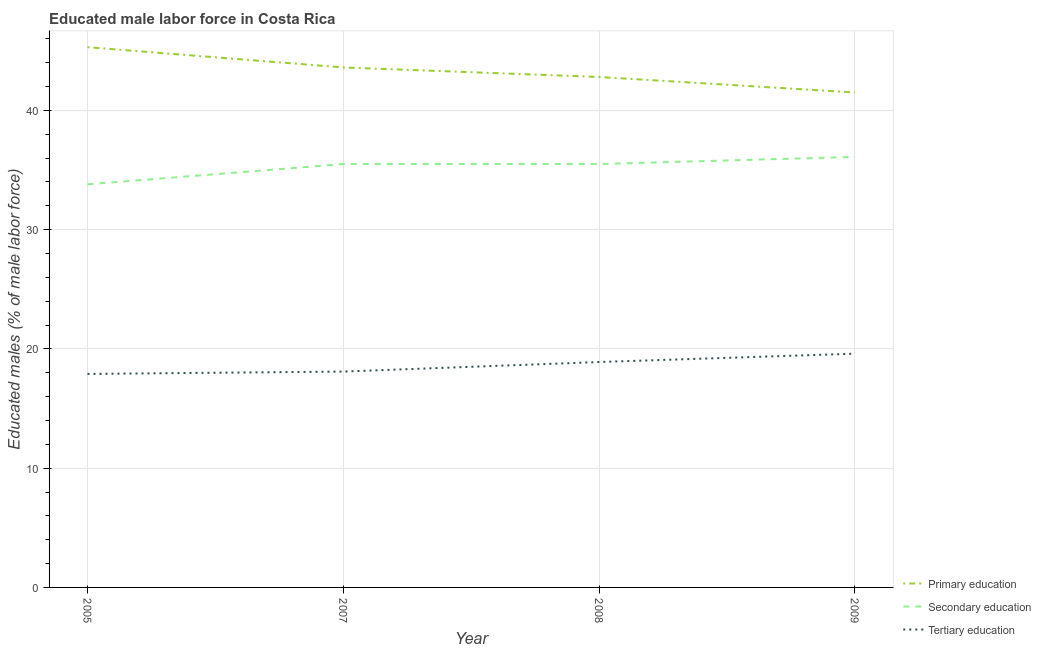Does the line corresponding to percentage of male labor force who received primary education intersect with the line corresponding to percentage of male labor force who received secondary education?
Offer a very short reply. No. What is the percentage of male labor force who received primary education in 2008?
Your answer should be compact. 42.8. Across all years, what is the maximum percentage of male labor force who received secondary education?
Provide a succinct answer. 36.1. Across all years, what is the minimum percentage of male labor force who received primary education?
Your response must be concise. 41.5. In which year was the percentage of male labor force who received tertiary education minimum?
Your answer should be compact. 2005. What is the total percentage of male labor force who received secondary education in the graph?
Ensure brevity in your answer.  140.9. What is the difference between the percentage of male labor force who received secondary education in 2005 and that in 2007?
Make the answer very short. -1.7. What is the difference between the percentage of male labor force who received tertiary education in 2008 and the percentage of male labor force who received secondary education in 2005?
Offer a terse response. -14.9. What is the average percentage of male labor force who received primary education per year?
Offer a very short reply. 43.3. What is the ratio of the percentage of male labor force who received tertiary education in 2008 to that in 2009?
Provide a succinct answer. 0.96. What is the difference between the highest and the second highest percentage of male labor force who received secondary education?
Keep it short and to the point. 0.6. What is the difference between the highest and the lowest percentage of male labor force who received tertiary education?
Your answer should be very brief. 1.7. Is it the case that in every year, the sum of the percentage of male labor force who received primary education and percentage of male labor force who received secondary education is greater than the percentage of male labor force who received tertiary education?
Offer a very short reply. Yes. How many lines are there?
Make the answer very short. 3. What is the difference between two consecutive major ticks on the Y-axis?
Make the answer very short. 10. Are the values on the major ticks of Y-axis written in scientific E-notation?
Keep it short and to the point. No. Does the graph contain any zero values?
Make the answer very short. No. Does the graph contain grids?
Make the answer very short. Yes. Where does the legend appear in the graph?
Give a very brief answer. Bottom right. What is the title of the graph?
Provide a succinct answer. Educated male labor force in Costa Rica. What is the label or title of the X-axis?
Provide a short and direct response. Year. What is the label or title of the Y-axis?
Ensure brevity in your answer.  Educated males (% of male labor force). What is the Educated males (% of male labor force) of Primary education in 2005?
Your response must be concise. 45.3. What is the Educated males (% of male labor force) in Secondary education in 2005?
Make the answer very short. 33.8. What is the Educated males (% of male labor force) in Tertiary education in 2005?
Your answer should be very brief. 17.9. What is the Educated males (% of male labor force) in Primary education in 2007?
Provide a succinct answer. 43.6. What is the Educated males (% of male labor force) in Secondary education in 2007?
Offer a very short reply. 35.5. What is the Educated males (% of male labor force) in Tertiary education in 2007?
Your answer should be very brief. 18.1. What is the Educated males (% of male labor force) of Primary education in 2008?
Ensure brevity in your answer.  42.8. What is the Educated males (% of male labor force) in Secondary education in 2008?
Make the answer very short. 35.5. What is the Educated males (% of male labor force) in Tertiary education in 2008?
Ensure brevity in your answer.  18.9. What is the Educated males (% of male labor force) of Primary education in 2009?
Give a very brief answer. 41.5. What is the Educated males (% of male labor force) of Secondary education in 2009?
Offer a very short reply. 36.1. What is the Educated males (% of male labor force) in Tertiary education in 2009?
Make the answer very short. 19.6. Across all years, what is the maximum Educated males (% of male labor force) of Primary education?
Offer a very short reply. 45.3. Across all years, what is the maximum Educated males (% of male labor force) of Secondary education?
Provide a succinct answer. 36.1. Across all years, what is the maximum Educated males (% of male labor force) in Tertiary education?
Your answer should be very brief. 19.6. Across all years, what is the minimum Educated males (% of male labor force) of Primary education?
Provide a short and direct response. 41.5. Across all years, what is the minimum Educated males (% of male labor force) of Secondary education?
Your response must be concise. 33.8. Across all years, what is the minimum Educated males (% of male labor force) of Tertiary education?
Provide a short and direct response. 17.9. What is the total Educated males (% of male labor force) of Primary education in the graph?
Ensure brevity in your answer.  173.2. What is the total Educated males (% of male labor force) in Secondary education in the graph?
Give a very brief answer. 140.9. What is the total Educated males (% of male labor force) in Tertiary education in the graph?
Your answer should be very brief. 74.5. What is the difference between the Educated males (% of male labor force) in Tertiary education in 2005 and that in 2007?
Give a very brief answer. -0.2. What is the difference between the Educated males (% of male labor force) in Tertiary education in 2005 and that in 2008?
Provide a succinct answer. -1. What is the difference between the Educated males (% of male labor force) of Primary education in 2005 and that in 2009?
Your answer should be very brief. 3.8. What is the difference between the Educated males (% of male labor force) in Tertiary education in 2007 and that in 2008?
Provide a succinct answer. -0.8. What is the difference between the Educated males (% of male labor force) of Primary education in 2007 and that in 2009?
Provide a short and direct response. 2.1. What is the difference between the Educated males (% of male labor force) in Secondary education in 2007 and that in 2009?
Ensure brevity in your answer.  -0.6. What is the difference between the Educated males (% of male labor force) in Tertiary education in 2007 and that in 2009?
Give a very brief answer. -1.5. What is the difference between the Educated males (% of male labor force) in Primary education in 2005 and the Educated males (% of male labor force) in Tertiary education in 2007?
Your response must be concise. 27.2. What is the difference between the Educated males (% of male labor force) in Primary education in 2005 and the Educated males (% of male labor force) in Tertiary education in 2008?
Offer a terse response. 26.4. What is the difference between the Educated males (% of male labor force) of Primary education in 2005 and the Educated males (% of male labor force) of Tertiary education in 2009?
Keep it short and to the point. 25.7. What is the difference between the Educated males (% of male labor force) of Secondary education in 2005 and the Educated males (% of male labor force) of Tertiary education in 2009?
Offer a very short reply. 14.2. What is the difference between the Educated males (% of male labor force) in Primary education in 2007 and the Educated males (% of male labor force) in Secondary education in 2008?
Your answer should be very brief. 8.1. What is the difference between the Educated males (% of male labor force) of Primary education in 2007 and the Educated males (% of male labor force) of Tertiary education in 2008?
Offer a terse response. 24.7. What is the difference between the Educated males (% of male labor force) of Secondary education in 2007 and the Educated males (% of male labor force) of Tertiary education in 2008?
Offer a terse response. 16.6. What is the difference between the Educated males (% of male labor force) in Primary education in 2007 and the Educated males (% of male labor force) in Secondary education in 2009?
Your answer should be very brief. 7.5. What is the difference between the Educated males (% of male labor force) of Primary education in 2008 and the Educated males (% of male labor force) of Tertiary education in 2009?
Provide a short and direct response. 23.2. What is the average Educated males (% of male labor force) of Primary education per year?
Offer a very short reply. 43.3. What is the average Educated males (% of male labor force) of Secondary education per year?
Offer a terse response. 35.23. What is the average Educated males (% of male labor force) of Tertiary education per year?
Ensure brevity in your answer.  18.62. In the year 2005, what is the difference between the Educated males (% of male labor force) in Primary education and Educated males (% of male labor force) in Tertiary education?
Your response must be concise. 27.4. In the year 2007, what is the difference between the Educated males (% of male labor force) in Primary education and Educated males (% of male labor force) in Secondary education?
Provide a short and direct response. 8.1. In the year 2008, what is the difference between the Educated males (% of male labor force) of Primary education and Educated males (% of male labor force) of Tertiary education?
Give a very brief answer. 23.9. In the year 2008, what is the difference between the Educated males (% of male labor force) of Secondary education and Educated males (% of male labor force) of Tertiary education?
Make the answer very short. 16.6. In the year 2009, what is the difference between the Educated males (% of male labor force) in Primary education and Educated males (% of male labor force) in Secondary education?
Provide a succinct answer. 5.4. In the year 2009, what is the difference between the Educated males (% of male labor force) in Primary education and Educated males (% of male labor force) in Tertiary education?
Make the answer very short. 21.9. What is the ratio of the Educated males (% of male labor force) in Primary education in 2005 to that in 2007?
Keep it short and to the point. 1.04. What is the ratio of the Educated males (% of male labor force) of Secondary education in 2005 to that in 2007?
Give a very brief answer. 0.95. What is the ratio of the Educated males (% of male labor force) of Tertiary education in 2005 to that in 2007?
Ensure brevity in your answer.  0.99. What is the ratio of the Educated males (% of male labor force) in Primary education in 2005 to that in 2008?
Provide a short and direct response. 1.06. What is the ratio of the Educated males (% of male labor force) in Secondary education in 2005 to that in 2008?
Ensure brevity in your answer.  0.95. What is the ratio of the Educated males (% of male labor force) in Tertiary education in 2005 to that in 2008?
Provide a succinct answer. 0.95. What is the ratio of the Educated males (% of male labor force) of Primary education in 2005 to that in 2009?
Make the answer very short. 1.09. What is the ratio of the Educated males (% of male labor force) in Secondary education in 2005 to that in 2009?
Give a very brief answer. 0.94. What is the ratio of the Educated males (% of male labor force) in Tertiary education in 2005 to that in 2009?
Give a very brief answer. 0.91. What is the ratio of the Educated males (% of male labor force) of Primary education in 2007 to that in 2008?
Provide a succinct answer. 1.02. What is the ratio of the Educated males (% of male labor force) in Tertiary education in 2007 to that in 2008?
Ensure brevity in your answer.  0.96. What is the ratio of the Educated males (% of male labor force) of Primary education in 2007 to that in 2009?
Your answer should be compact. 1.05. What is the ratio of the Educated males (% of male labor force) in Secondary education in 2007 to that in 2009?
Your answer should be compact. 0.98. What is the ratio of the Educated males (% of male labor force) of Tertiary education in 2007 to that in 2009?
Give a very brief answer. 0.92. What is the ratio of the Educated males (% of male labor force) in Primary education in 2008 to that in 2009?
Provide a short and direct response. 1.03. What is the ratio of the Educated males (% of male labor force) of Secondary education in 2008 to that in 2009?
Keep it short and to the point. 0.98. What is the difference between the highest and the lowest Educated males (% of male labor force) in Primary education?
Make the answer very short. 3.8. What is the difference between the highest and the lowest Educated males (% of male labor force) in Secondary education?
Make the answer very short. 2.3. 